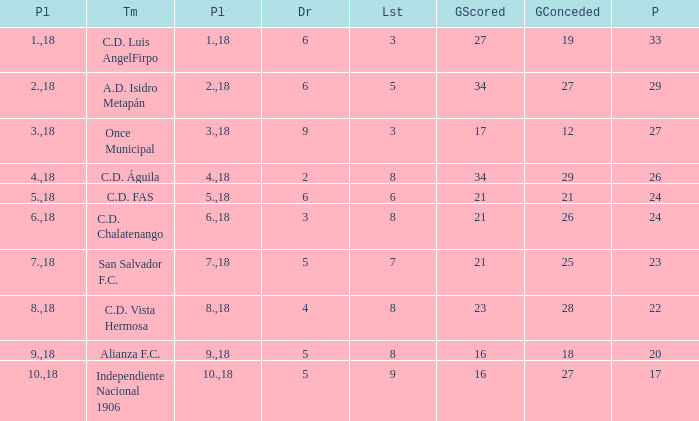What were the goal conceded that had a lost greater than 8 and more than 17 points? None. 